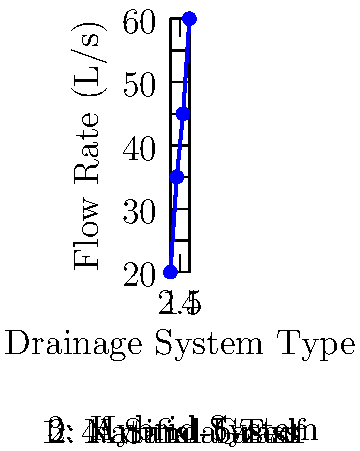Based on the graph showing water flow rates for different soccer field drainage systems, which type of system has the highest flow rate and how much higher is it compared to the natural grass system? To answer this question, we need to follow these steps:

1. Identify the highest flow rate:
   Looking at the y-axis (Flow Rate in L/s), we can see that the highest point on the graph corresponds to 60 L/s.

2. Determine which system this flow rate belongs to:
   The x-axis shows that the highest point (60 L/s) corresponds to System 4, which is the Sand-based system.

3. Find the flow rate for the natural grass system:
   System 1 represents the Natural Grass system, which has a flow rate of 20 L/s.

4. Calculate the difference:
   To find how much higher the Sand-based system's flow rate is, we subtract:
   $$ 60 \, L/s - 20 \, L/s = 40 \, L/s $$

Therefore, the Sand-based system has the highest flow rate, and it is 40 L/s higher than the Natural Grass system.
Answer: Sand-based; 40 L/s higher 